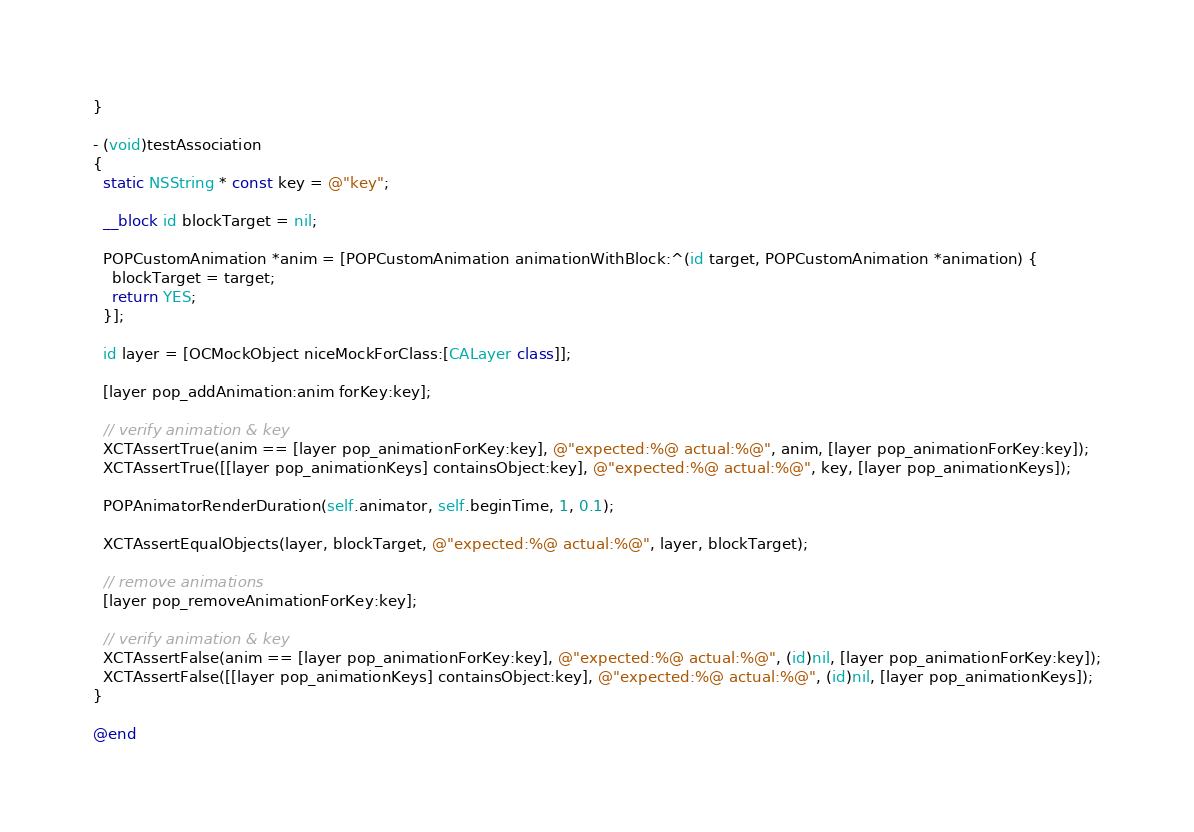<code> <loc_0><loc_0><loc_500><loc_500><_ObjectiveC_>}

- (void)testAssociation
{
  static NSString * const key = @"key";
  
  __block id blockTarget = nil;
  
  POPCustomAnimation *anim = [POPCustomAnimation animationWithBlock:^(id target, POPCustomAnimation *animation) {
    blockTarget = target;
    return YES;
  }];

  id layer = [OCMockObject niceMockForClass:[CALayer class]];

  [layer pop_addAnimation:anim forKey:key];
  
  // verify animation & key
  XCTAssertTrue(anim == [layer pop_animationForKey:key], @"expected:%@ actual:%@", anim, [layer pop_animationForKey:key]);
  XCTAssertTrue([[layer pop_animationKeys] containsObject:key], @"expected:%@ actual:%@", key, [layer pop_animationKeys]);
  
  POPAnimatorRenderDuration(self.animator, self.beginTime, 1, 0.1);

  XCTAssertEqualObjects(layer, blockTarget, @"expected:%@ actual:%@", layer, blockTarget);
  
  // remove animations
  [layer pop_removeAnimationForKey:key];

  // verify animation & key
  XCTAssertFalse(anim == [layer pop_animationForKey:key], @"expected:%@ actual:%@", (id)nil, [layer pop_animationForKey:key]);
  XCTAssertFalse([[layer pop_animationKeys] containsObject:key], @"expected:%@ actual:%@", (id)nil, [layer pop_animationKeys]);
}

@end
</code> 